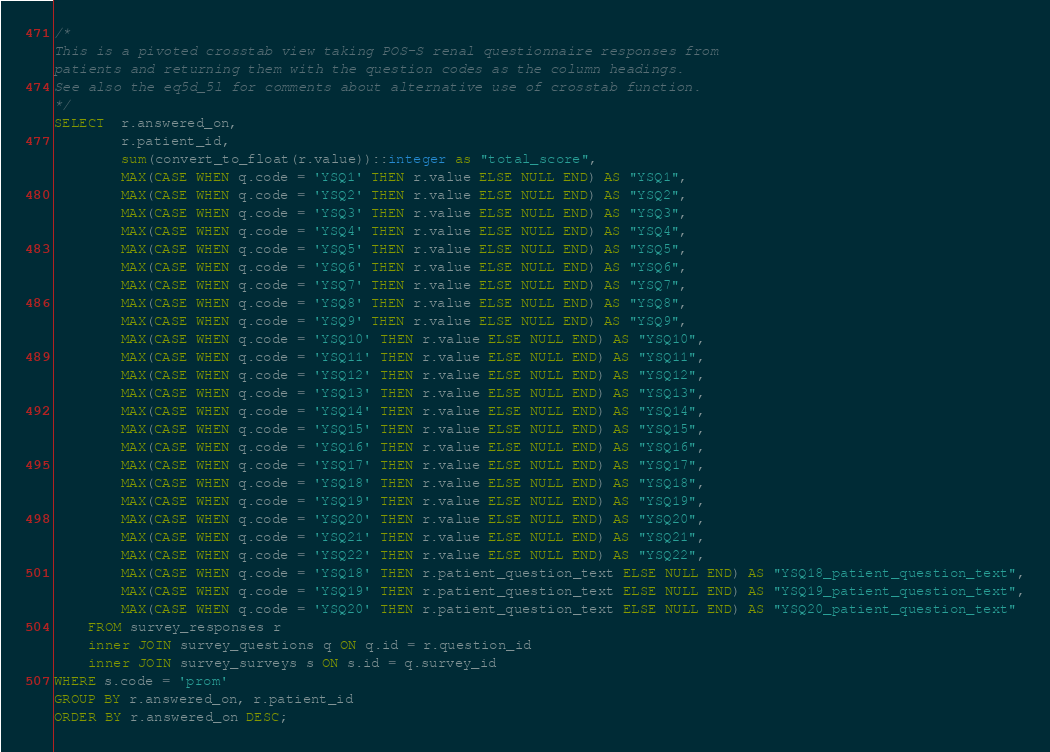Convert code to text. <code><loc_0><loc_0><loc_500><loc_500><_SQL_>/*
This is a pivoted crosstab view taking POS-S renal questionnaire responses from
patients and returning them with the question codes as the column headings.
See also the eq5d_5l for comments about alternative use of crosstab function.
*/
SELECT  r.answered_on,
        r.patient_id,
        sum(convert_to_float(r.value))::integer as "total_score",
        MAX(CASE WHEN q.code = 'YSQ1' THEN r.value ELSE NULL END) AS "YSQ1",
        MAX(CASE WHEN q.code = 'YSQ2' THEN r.value ELSE NULL END) AS "YSQ2",
        MAX(CASE WHEN q.code = 'YSQ3' THEN r.value ELSE NULL END) AS "YSQ3",
        MAX(CASE WHEN q.code = 'YSQ4' THEN r.value ELSE NULL END) AS "YSQ4",
        MAX(CASE WHEN q.code = 'YSQ5' THEN r.value ELSE NULL END) AS "YSQ5",
        MAX(CASE WHEN q.code = 'YSQ6' THEN r.value ELSE NULL END) AS "YSQ6",
        MAX(CASE WHEN q.code = 'YSQ7' THEN r.value ELSE NULL END) AS "YSQ7",
        MAX(CASE WHEN q.code = 'YSQ8' THEN r.value ELSE NULL END) AS "YSQ8",
        MAX(CASE WHEN q.code = 'YSQ9' THEN r.value ELSE NULL END) AS "YSQ9",
        MAX(CASE WHEN q.code = 'YSQ10' THEN r.value ELSE NULL END) AS "YSQ10",
        MAX(CASE WHEN q.code = 'YSQ11' THEN r.value ELSE NULL END) AS "YSQ11",
        MAX(CASE WHEN q.code = 'YSQ12' THEN r.value ELSE NULL END) AS "YSQ12",
        MAX(CASE WHEN q.code = 'YSQ13' THEN r.value ELSE NULL END) AS "YSQ13",
        MAX(CASE WHEN q.code = 'YSQ14' THEN r.value ELSE NULL END) AS "YSQ14",
        MAX(CASE WHEN q.code = 'YSQ15' THEN r.value ELSE NULL END) AS "YSQ15",
        MAX(CASE WHEN q.code = 'YSQ16' THEN r.value ELSE NULL END) AS "YSQ16",
        MAX(CASE WHEN q.code = 'YSQ17' THEN r.value ELSE NULL END) AS "YSQ17",
        MAX(CASE WHEN q.code = 'YSQ18' THEN r.value ELSE NULL END) AS "YSQ18",
        MAX(CASE WHEN q.code = 'YSQ19' THEN r.value ELSE NULL END) AS "YSQ19",
        MAX(CASE WHEN q.code = 'YSQ20' THEN r.value ELSE NULL END) AS "YSQ20",
        MAX(CASE WHEN q.code = 'YSQ21' THEN r.value ELSE NULL END) AS "YSQ21",
        MAX(CASE WHEN q.code = 'YSQ22' THEN r.value ELSE NULL END) AS "YSQ22",
        MAX(CASE WHEN q.code = 'YSQ18' THEN r.patient_question_text ELSE NULL END) AS "YSQ18_patient_question_text",
        MAX(CASE WHEN q.code = 'YSQ19' THEN r.patient_question_text ELSE NULL END) AS "YSQ19_patient_question_text",
        MAX(CASE WHEN q.code = 'YSQ20' THEN r.patient_question_text ELSE NULL END) AS "YSQ20_patient_question_text"
    FROM survey_responses r
    inner JOIN survey_questions q ON q.id = r.question_id
    inner JOIN survey_surveys s ON s.id = q.survey_id
WHERE s.code = 'prom'
GROUP BY r.answered_on, r.patient_id
ORDER BY r.answered_on DESC;
</code> 